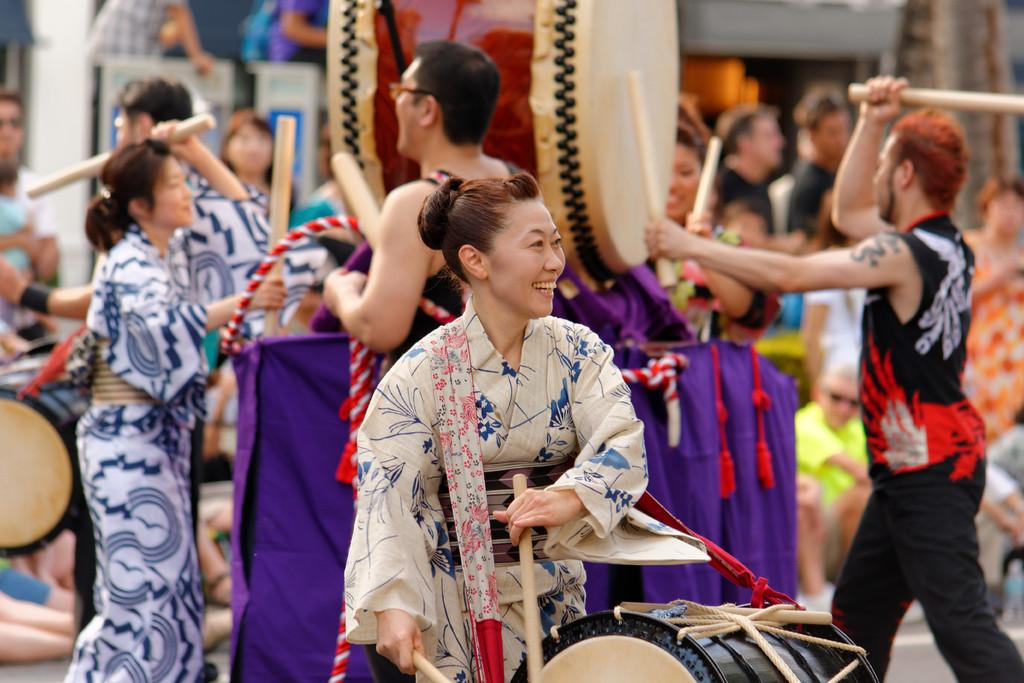What is happening in the image? There is a group of people in the image, and they are playing musical instruments. What are the people doing in the image? The people are playing musical instruments. What type of account is required to access the payment system in the image? There is no payment system or account mentioned in the image; it only shows a group of people playing musical instruments. 